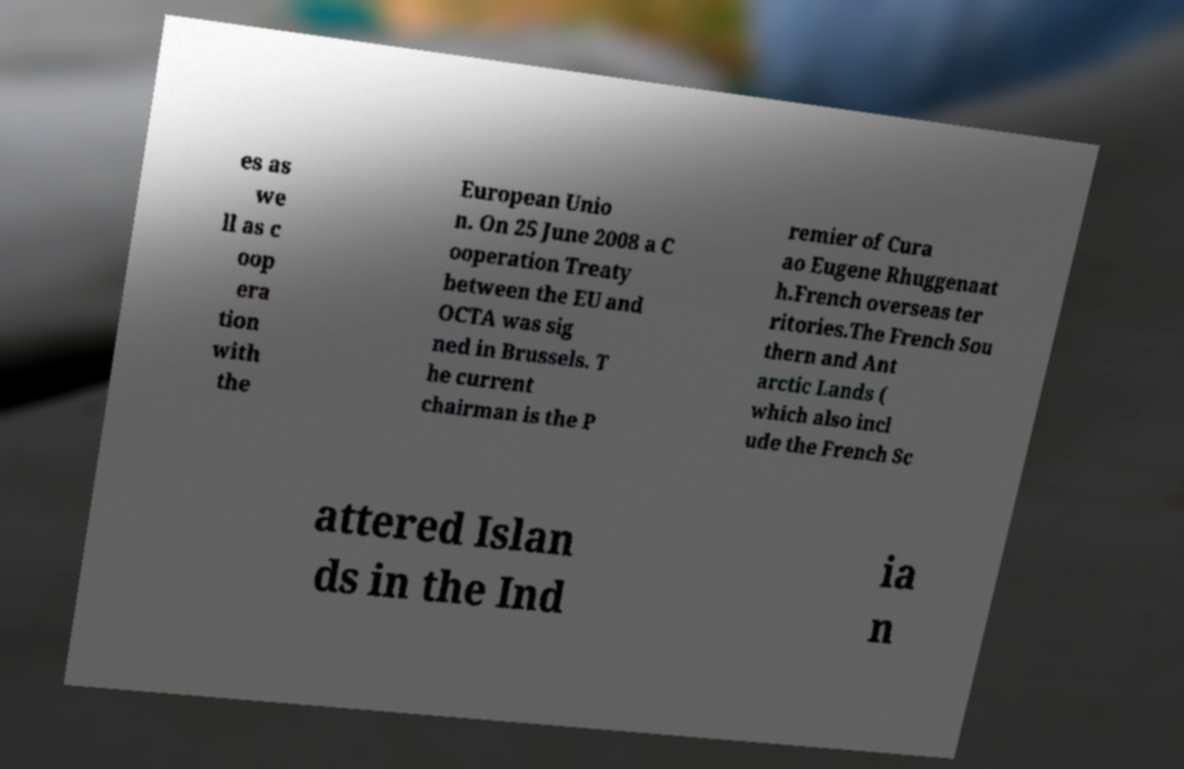Please read and relay the text visible in this image. What does it say? es as we ll as c oop era tion with the European Unio n. On 25 June 2008 a C ooperation Treaty between the EU and OCTA was sig ned in Brussels. T he current chairman is the P remier of Cura ao Eugene Rhuggenaat h.French overseas ter ritories.The French Sou thern and Ant arctic Lands ( which also incl ude the French Sc attered Islan ds in the Ind ia n 